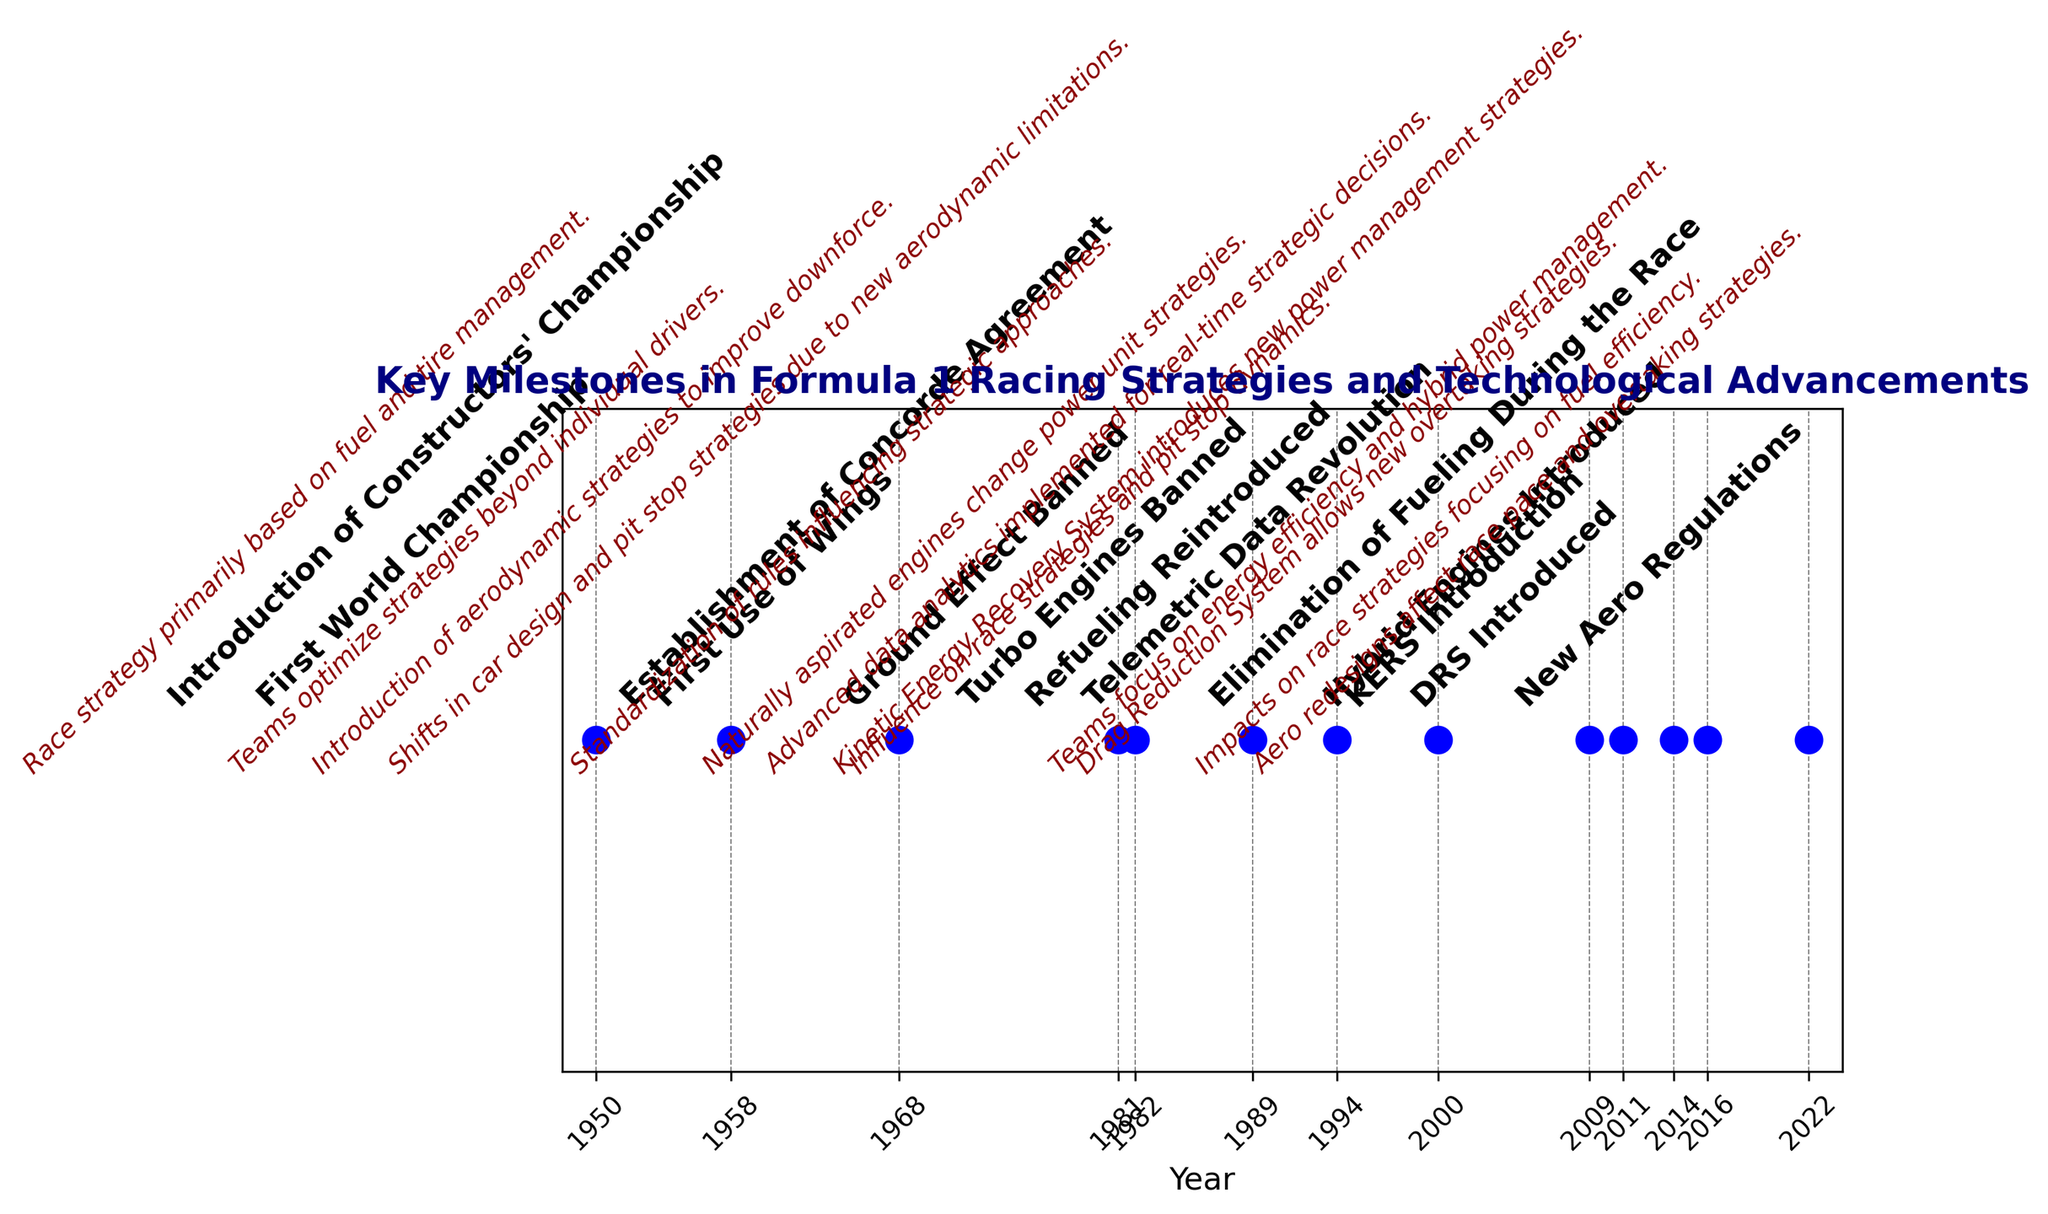What year did Formula 1 reintroduce refueling? The figure shows key milestones with annotations for each year. Look for the milestone labeled 'Refueling Reintroduced' and note the corresponding year.
Answer: 1994 Which event occurred first: The introduction of DRS or the introduction of KERS? Compare the placement of the 'DRS Introduced' and 'KERS Introduction' annotations on the timeline. Since 'KERS Introduction' is marked at 2009 and 'DRS Introduced' at 2011, KERS was introduced first.
Answer: KERS Introduction Between what years did the first use of wings and the banning of turbo engines occur? Locate the milestones for 'First Use of Wings' and 'Turbo Engines Banned'. 'First Use of Wings' happened in 1968 and 'Turbo Engines Banned' occurred in 1989.
Answer: 1968 and 1989 What are the milestones that occurred in the 2000s? Identify the milestones with years in the 2000s. According to the plot, 'Telemetric Data Revolution' (2000), 'KERS Introduction' (2009), and 'DRS Introduced' (2011) occurred in this period.
Answer: Telemetric Data Revolution, KERS Introduction, DRS Introduced How many milestones are depicted in the timeline? Count the number of milestones listed in the plot, each marked by a vertical line and an annotation. Counting all the milestones, there are 13.
Answer: 13 Which milestone had a technical focus on engines introduced and in what year did it occur? Look for the milestone descriptions that mention engines. The milestone 'Hybrid Engines Introduced' focuses on engines and occurred in 2014.
Answer: Hybrid Engines Introduced in 2014 In which year were both aerodynamic strategies and the Constructors' Championship introduced? Identify the years for 'First Use of Wings' (aerodynamic strategies) and 'Introduction of Constructors' Championship.' The aerodynamic strategies started in 1968 and the Constructors' Championship was introduced in 1958. Therefore, they were not introduced in the same year.
Answer: Never in the same year From the information given, which milestone directly affected race pace and overtaking strategies in 2022? Refer to the milestone details for 2022. 'New Aero Regulations' in 2022 affects race pace and overtaking strategies.
Answer: New Aero Regulations Which milestone marked the end of refueling during the race, and when did this change occur? Find the specific milestone addressing fueling changes. 'Elimination of Fueling During the Race' occurred in 2016.
Answer: Elimination of Fueling During the Race in 2016 